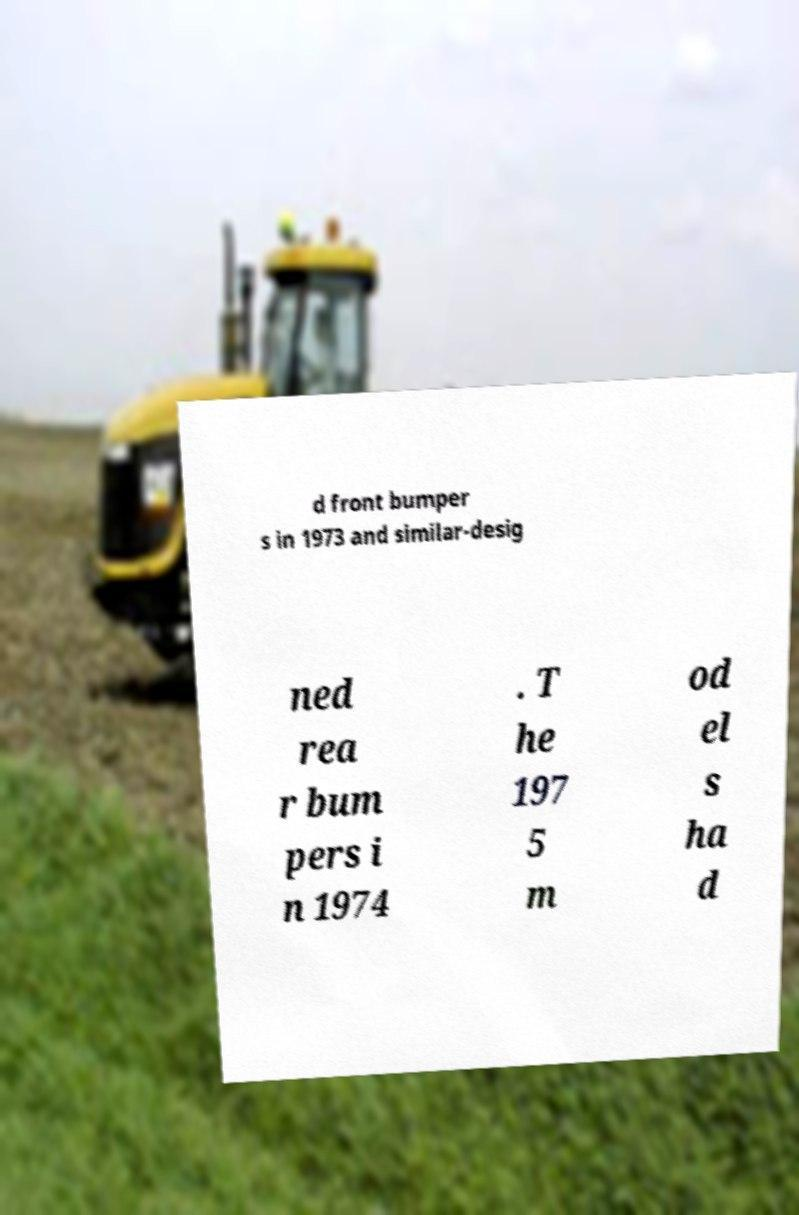Can you read and provide the text displayed in the image?This photo seems to have some interesting text. Can you extract and type it out for me? d front bumper s in 1973 and similar-desig ned rea r bum pers i n 1974 . T he 197 5 m od el s ha d 